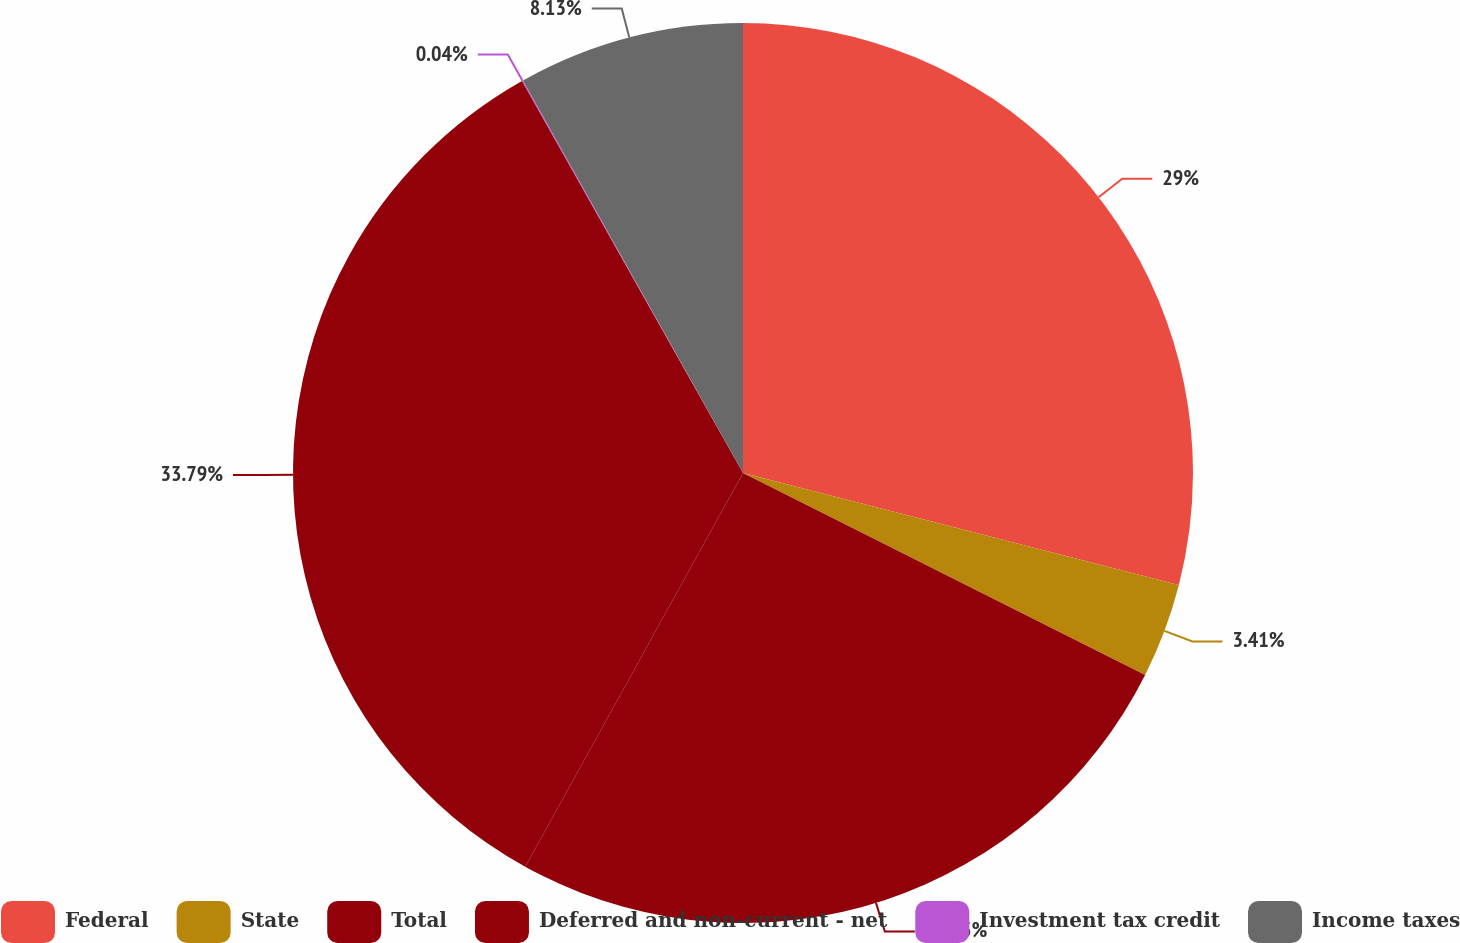<chart> <loc_0><loc_0><loc_500><loc_500><pie_chart><fcel>Federal<fcel>State<fcel>Total<fcel>Deferred and non-current - net<fcel>Investment tax credit<fcel>Income taxes<nl><fcel>29.0%<fcel>3.41%<fcel>25.63%<fcel>33.79%<fcel>0.04%<fcel>8.13%<nl></chart> 